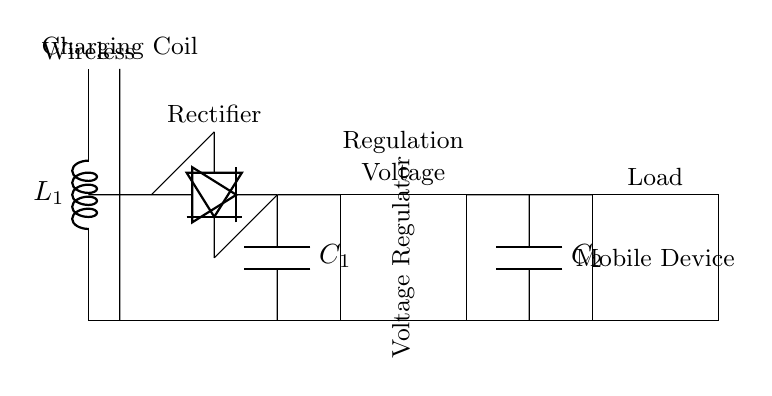What is the first component in the circuit? The first component depicted in the circuit diagram is the wireless charging coil labeled as L1, which is positioned at the top left of the diagram.
Answer: wireless charging coil How many diodes are present? The circuit contains two diodes, indicated in the diagram, which convert alternating current to direct current in the rectifier section.
Answer: 2 What does the capacitor labeled C1 do? Capacitor C1 is a smoothing capacitor that stabilizes the output voltage after the rectification process, ensuring that the power supply to the load is consistent.
Answer: smoothing What is the main function of the voltage regulator? The voltage regulator ensures that the output voltage remains within a specific range, despite variations in input voltage or load conditions, keeping the mobile device powered effectively.
Answer: regulation Which component is directly connected to the mobile device? The output capacitor C2 is directly linked to the mobile device, providing a stable power supply by smoothing the voltage output.
Answer: output capacitor How does the wireless charging coil influence the power supply? The wireless charging coil generates an alternating electromagnetic field, which induces a current in the receiver coil of the mobile device, enabling the wireless charging process.
Answer: induces current What does the term "load" refer to in this circuit? In the context of the circuit diagram, the term "load" refers to the mobile device that consumes power supplied by the circuit.
Answer: mobile device 